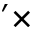Convert formula to latex. <formula><loc_0><loc_0><loc_500><loc_500>^ { \prime } \times</formula> 